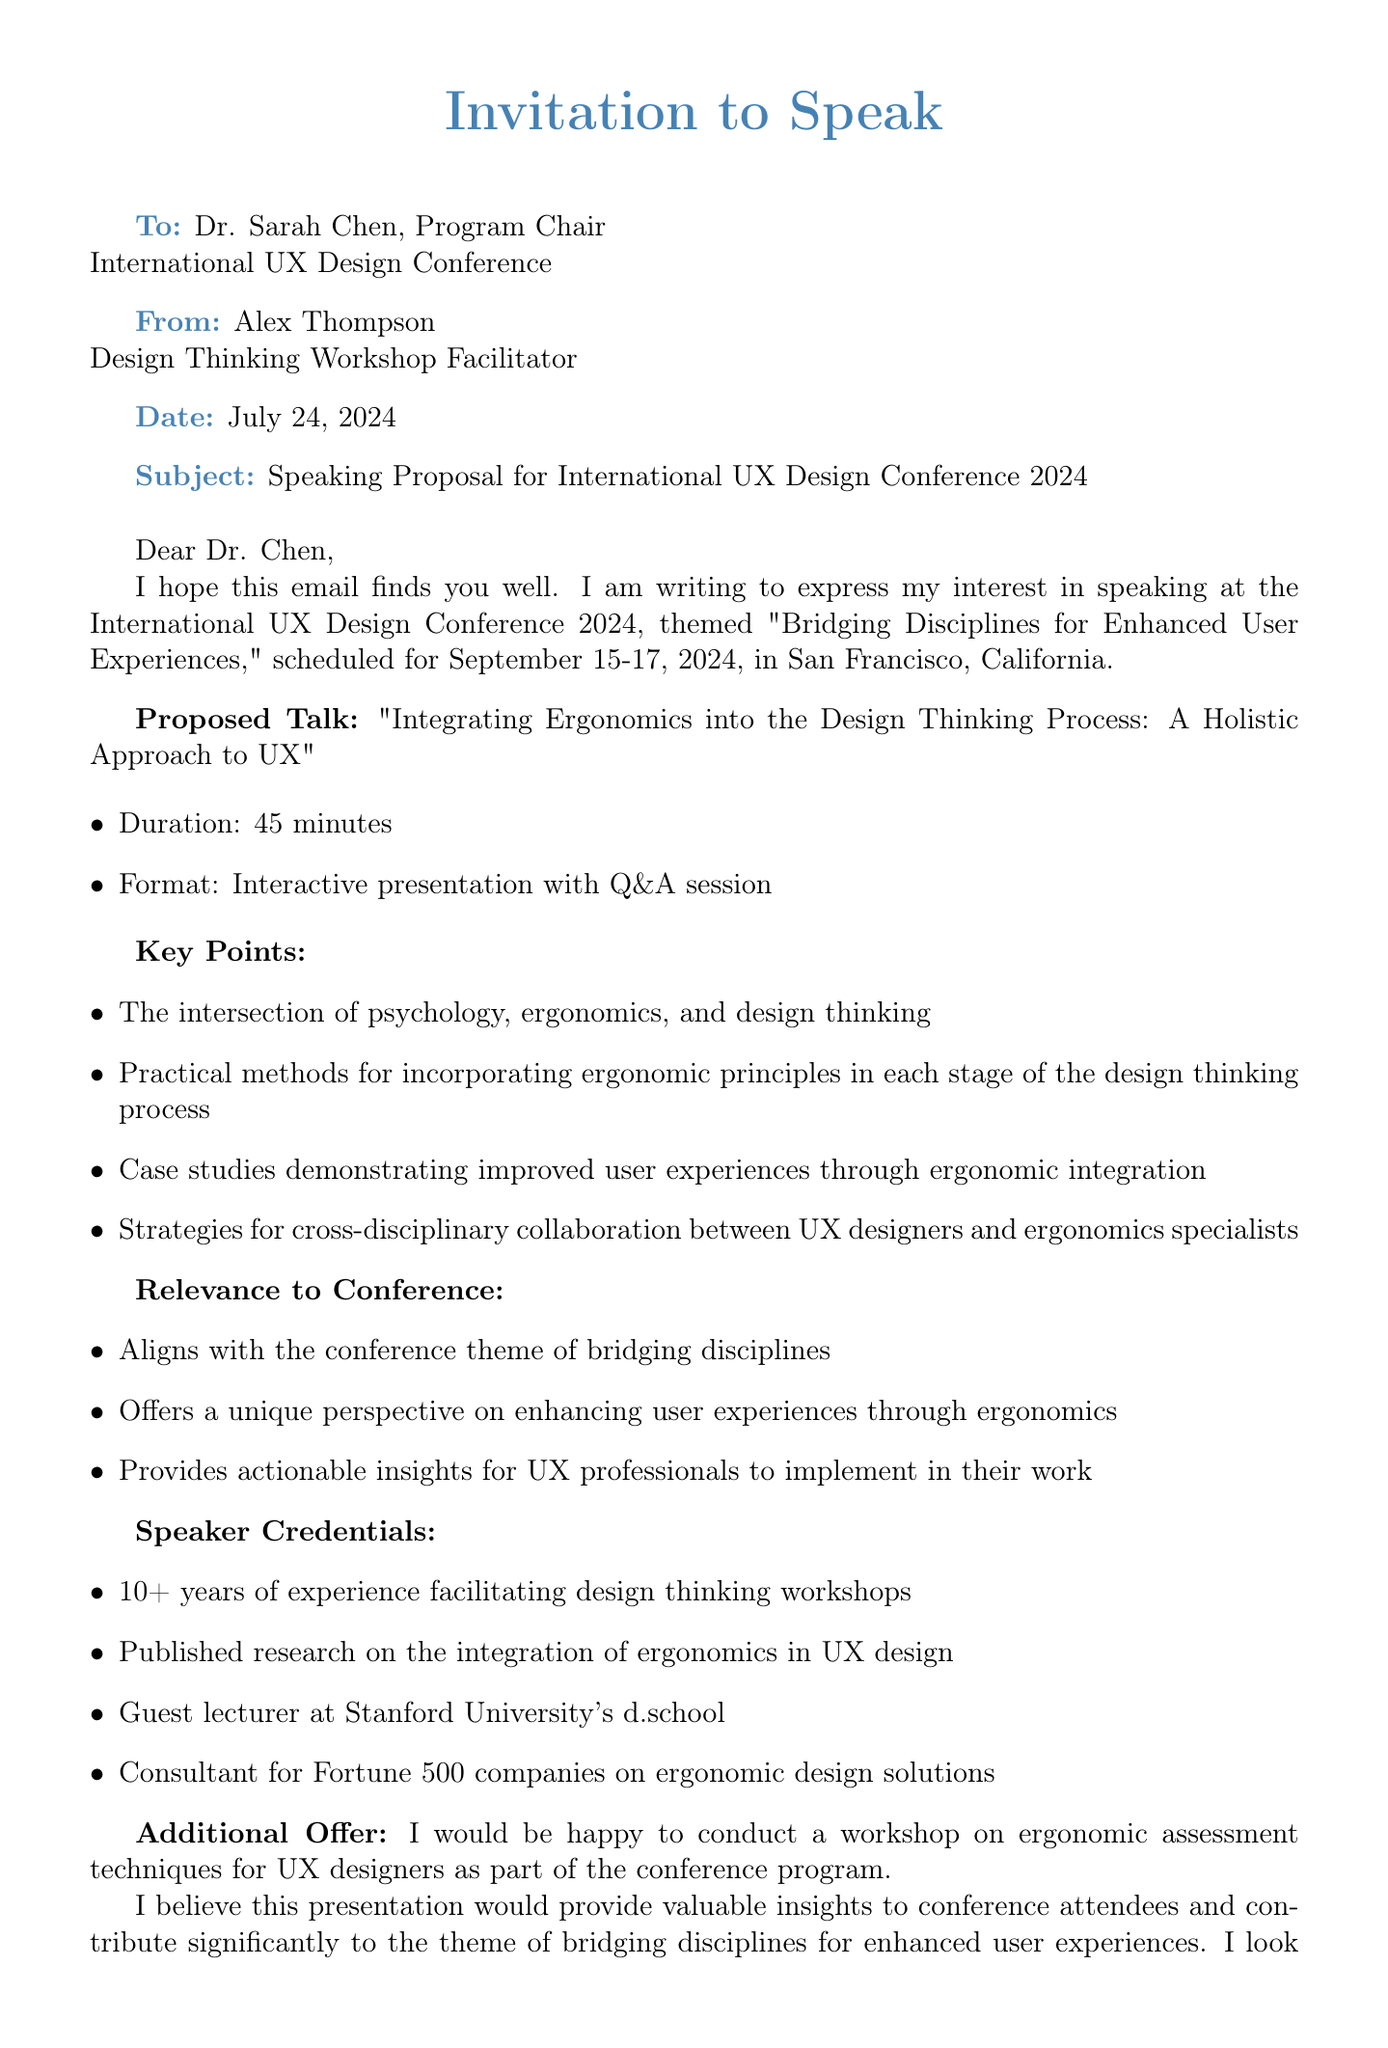what is the name of the conference? The conference is referred to as the International UX Design Conference 2024 in the document.
Answer: International UX Design Conference 2024 who is the recipient of the email? The document specifies that the recipient is Dr. Sarah Chen, the Program Chair.
Answer: Dr. Sarah Chen what are the dates of the conference? The email states the conference is scheduled for September 15-17, 2024.
Answer: September 15-17, 2024 what is the proposed talk title? The document mentions the proposed talk is titled "Integrating Ergonomics into the Design Thinking Process: A Holistic Approach to UX."
Answer: Integrating Ergonomics into the Design Thinking Process: A Holistic Approach to UX how long is the duration of the proposed talk? The email indicates that the proposed talk has a duration of 45 minutes.
Answer: 45 minutes what is one key point from the proposed talk? The document lists several key points, one of which is the intersection of psychology, ergonomics, and design thinking.
Answer: The intersection of psychology, ergonomics, and design thinking how many years of experience does the speaker have? The email states that the speaker has over 10 years of experience facilitating design thinking workshops.
Answer: 10+ years what additional offer does the speaker make? The document indicates an additional offer for conducting a workshop on ergonomic assessment techniques for UX designers.
Answer: Workshop on ergonomic assessment techniques for UX designers how does the proposed talk align with the conference theme? The email describes that the talk aligns with the conference theme of bridging disciplines by offering a unique perspective on enhancing user experiences.
Answer: Aligns with the conference theme of bridging disciplines 